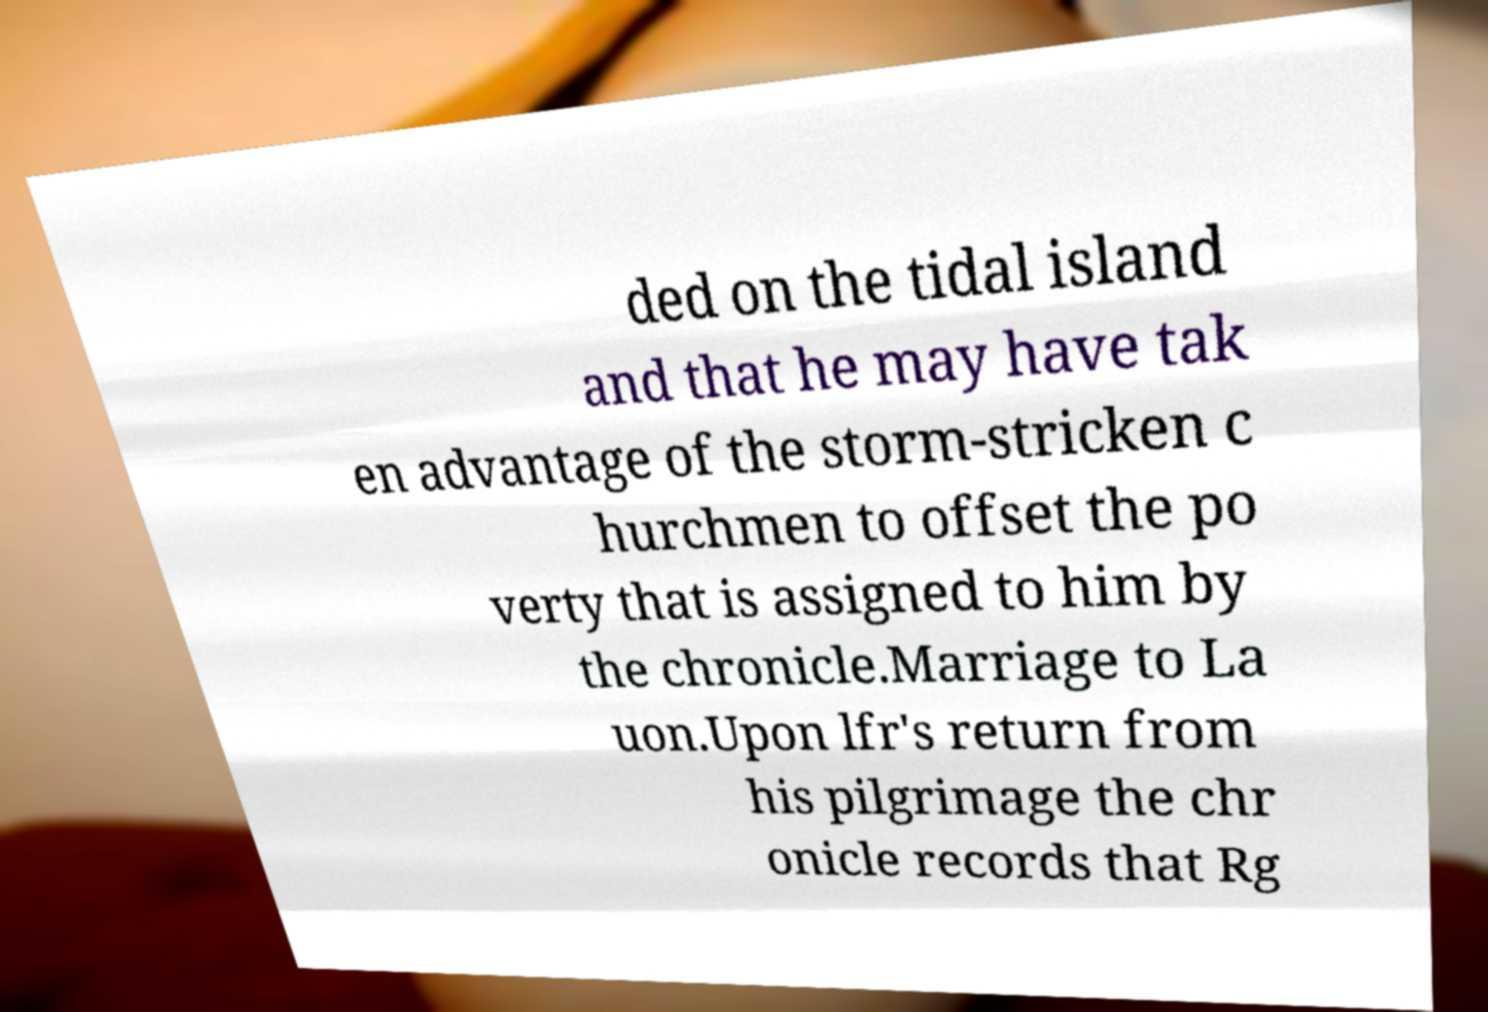Could you assist in decoding the text presented in this image and type it out clearly? ded on the tidal island and that he may have tak en advantage of the storm-stricken c hurchmen to offset the po verty that is assigned to him by the chronicle.Marriage to La uon.Upon lfr's return from his pilgrimage the chr onicle records that Rg 